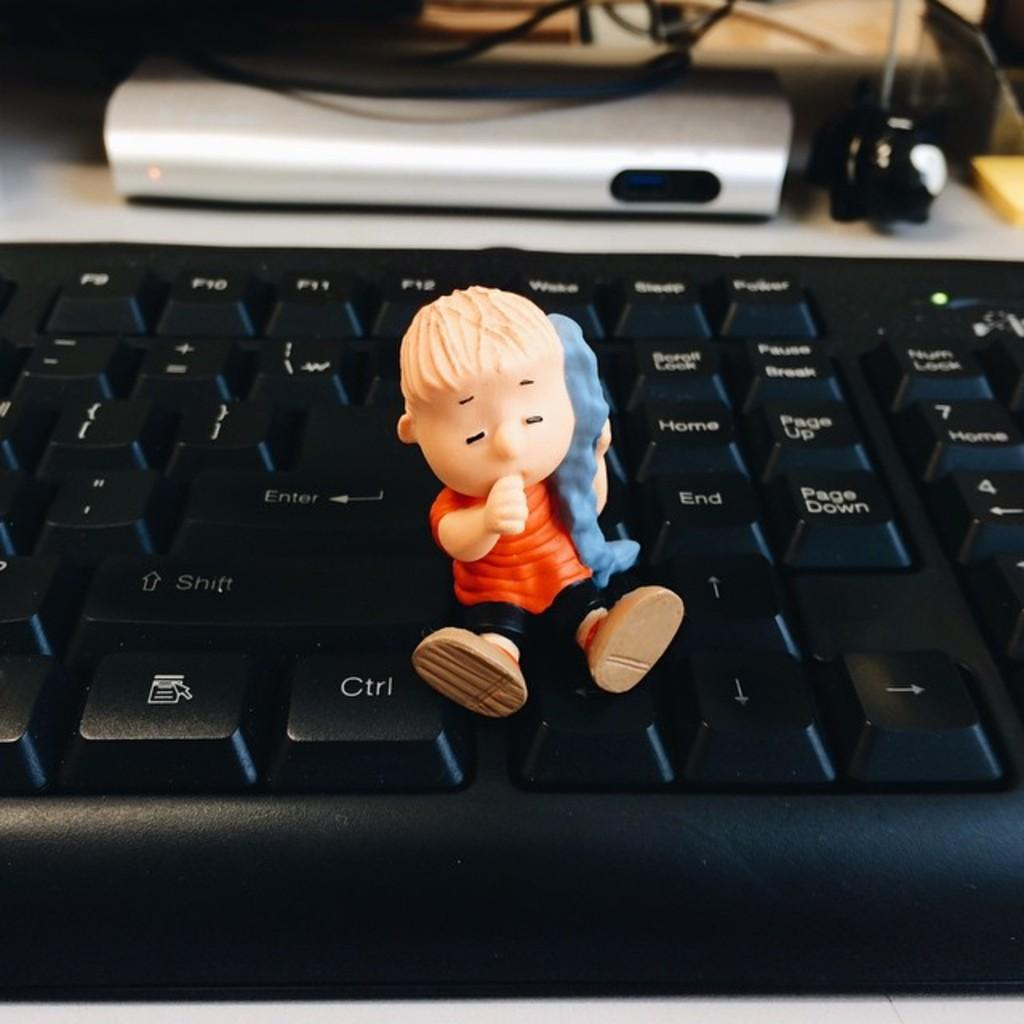<image>
Create a compact narrative representing the image presented. A Peanuts character figuring sits just next to the Ctrl button on a black keyboard. 